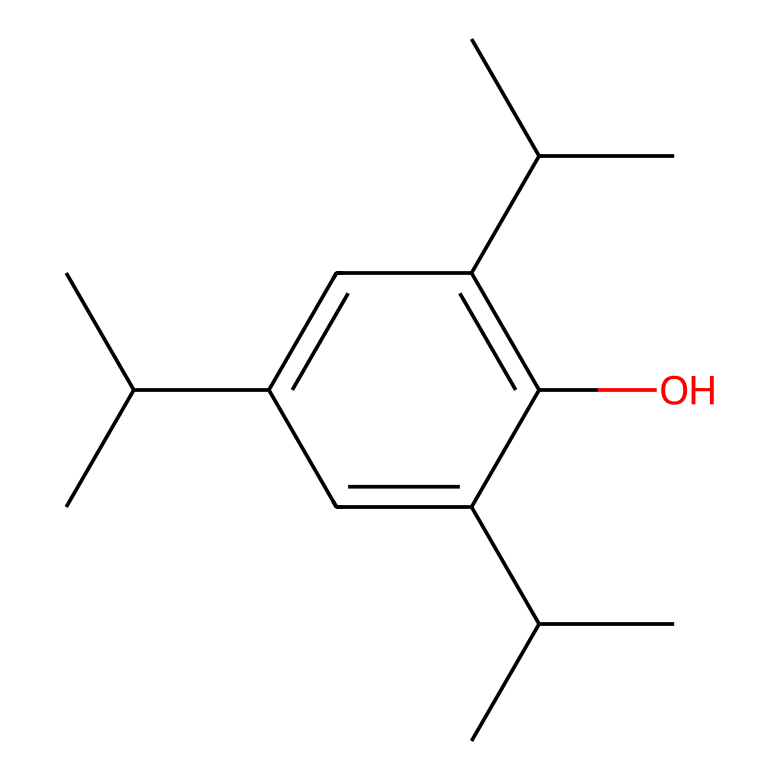What is the primary use of this drug? This chemical, Propofol, is widely recognized for its use as a general anesthetic in medical settings.
Answer: general anesthetic How many carbon atoms are present in this chemical? By analyzing the SMILES representation, we count the number of "C" letters to determine that there are 15 carbon atoms in Propofol.
Answer: 15 What type of compound is Propofol classified as? The presence of a hydroxyl group (-OH) and the carbon chain structure indicates that Propofol is classified as a phenolic compound and an aliphatic hydrocarbon.
Answer: phenolic compound What is the impact of the branched structure on the pharmacokinetics of this drug? The branched chain structure of Propofol enhances its lipophilicity, leading to rapid distribution across cell membranes, which influences its quick onset of action in pharmacokinetics.
Answer: enhances lipophilicity Is Propofol water-soluble? Based on its chemical structure that features a hydrophobic hydrocarbon tail and a hydrophilic hydroxyl group, it is mostly oil-soluble and only slightly soluble in water.
Answer: slightly What effect does the hydroxyl group have on this drug? The presence of the hydroxyl group (-OH) contributes to Propofol's increased solubility in lipids and affects its pharmacodynamics, aiding in its mechanism of action as a central nervous system depressant.
Answer: increased solubility What is the predicted half-life of Propofol? The typical half-life of Propofol is approximately 30 to 60 minutes, indicating its rapid metabolism and clearance from the body.
Answer: 30 to 60 minutes 